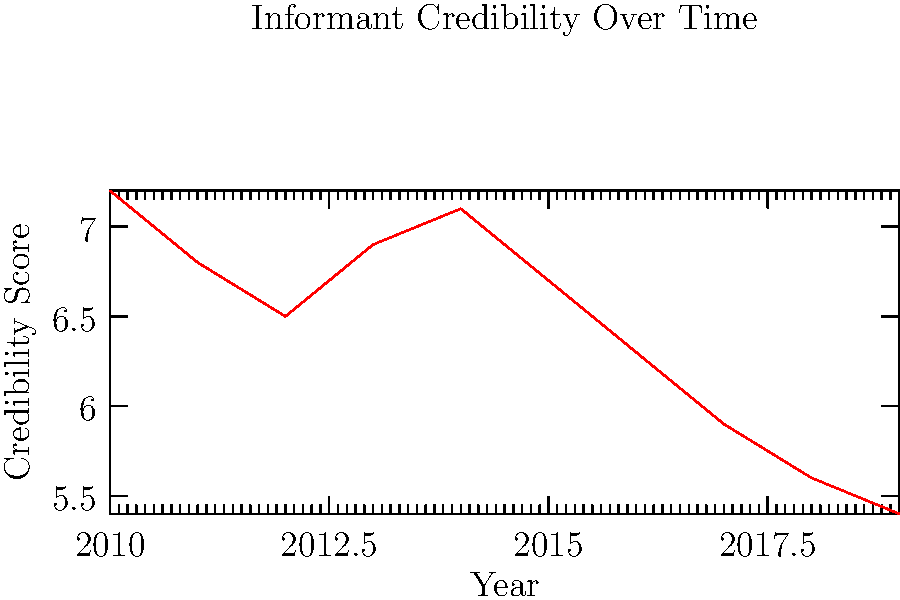Based on the line chart displaying informant credibility scores from 2010 to 2019, what is the overall trend in the reliability of informants over this period, and what might be a potential explanation for this trend from an ethical perspective in criminal investigations? To answer this question, we need to analyze the trend in the line chart and consider its ethical implications:

1. Observe the overall trend:
   - In 2010, the credibility score starts at 7.2.
   - By 2019, the score has decreased to 5.4.
   - There are some fluctuations, but the general trend is downward.

2. Calculate the total change:
   - Change in credibility = Final score - Initial score
   - Change = 5.4 - 7.2 = -1.8

3. Interpret the trend:
   - The negative change indicates a decline in informant credibility over time.
   - This suggests that informants have become less reliable in criminal investigations from 2010 to 2019.

4. Consider ethical implications:
   - Declining credibility might indicate increased awareness of the ethical concerns surrounding informant use.
   - Investigators may be more critical in evaluating informant information due to ethical considerations.
   - There could be growing recognition of the potential for false information or coercion in informant testimonies.
   - Stricter ethical guidelines for working with informants may have been implemented, leading to more scrutiny.

5. Potential explanation:
   - The trend could reflect a shift towards more ethical practices in criminal investigations.
   - Increased transparency and accountability in the justice system may have exposed flaws in relying heavily on informants.
   - Growing emphasis on evidence-based practices might have reduced the perceived value of informant testimony.
Answer: Declining reliability; possibly due to increased ethical scrutiny and awareness of potential issues with informant testimony. 